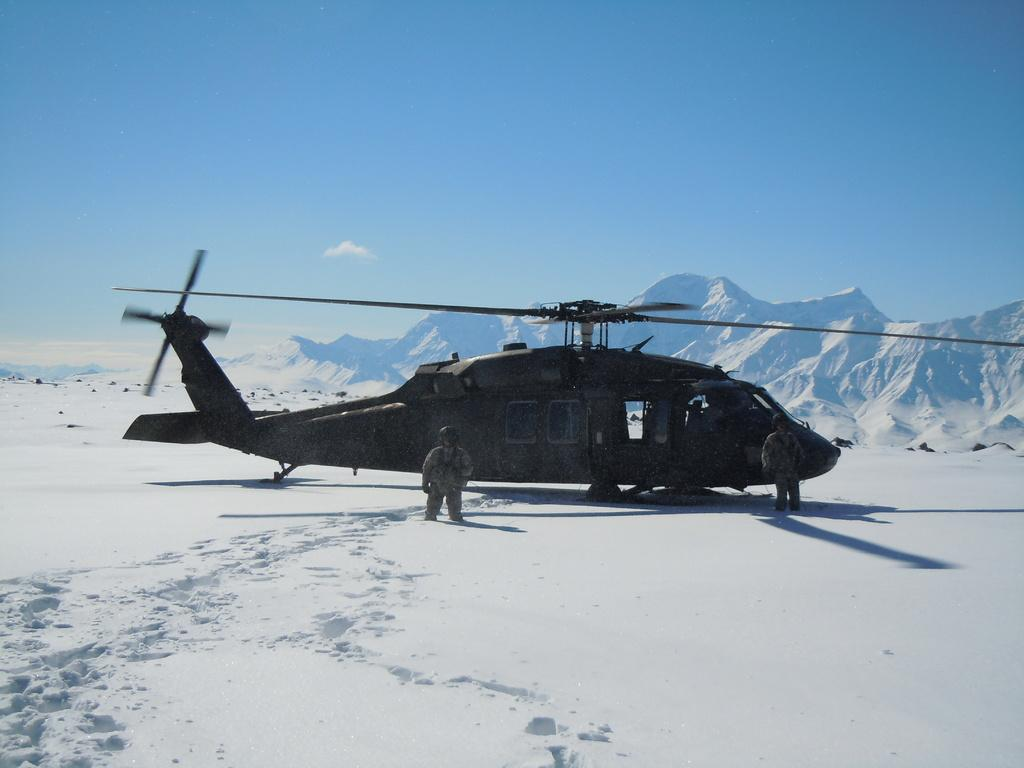What is the main subject of the image? The main subject of the image is a helicopter. Can you describe the people in the image? There are two people standing in the image. What is the weather like in the image? The image shows snow, indicating a cold and likely wintery environment. What else can be seen in the sky? The sky is visible in the image, but no specific details about the sky are mentioned in the facts. What type of truck can be seen driving through the snow in the image? There is no truck present in the image; it features a helicopter and two people standing in the snow. 